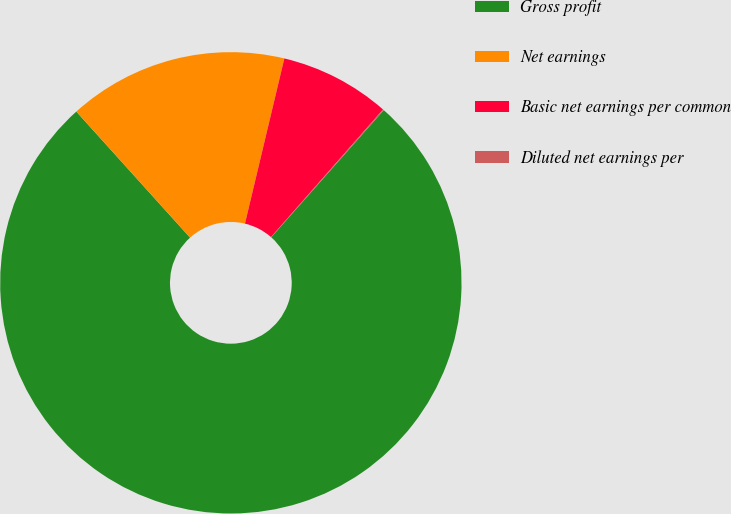<chart> <loc_0><loc_0><loc_500><loc_500><pie_chart><fcel>Gross profit<fcel>Net earnings<fcel>Basic net earnings per common<fcel>Diluted net earnings per<nl><fcel>76.78%<fcel>15.41%<fcel>7.74%<fcel>0.07%<nl></chart> 